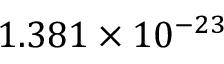<formula> <loc_0><loc_0><loc_500><loc_500>1 . 3 8 1 \times 1 0 ^ { - 2 3 }</formula> 